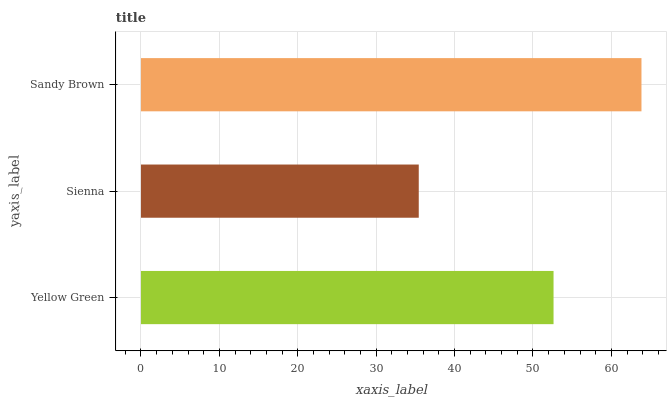Is Sienna the minimum?
Answer yes or no. Yes. Is Sandy Brown the maximum?
Answer yes or no. Yes. Is Sandy Brown the minimum?
Answer yes or no. No. Is Sienna the maximum?
Answer yes or no. No. Is Sandy Brown greater than Sienna?
Answer yes or no. Yes. Is Sienna less than Sandy Brown?
Answer yes or no. Yes. Is Sienna greater than Sandy Brown?
Answer yes or no. No. Is Sandy Brown less than Sienna?
Answer yes or no. No. Is Yellow Green the high median?
Answer yes or no. Yes. Is Yellow Green the low median?
Answer yes or no. Yes. Is Sandy Brown the high median?
Answer yes or no. No. Is Sienna the low median?
Answer yes or no. No. 